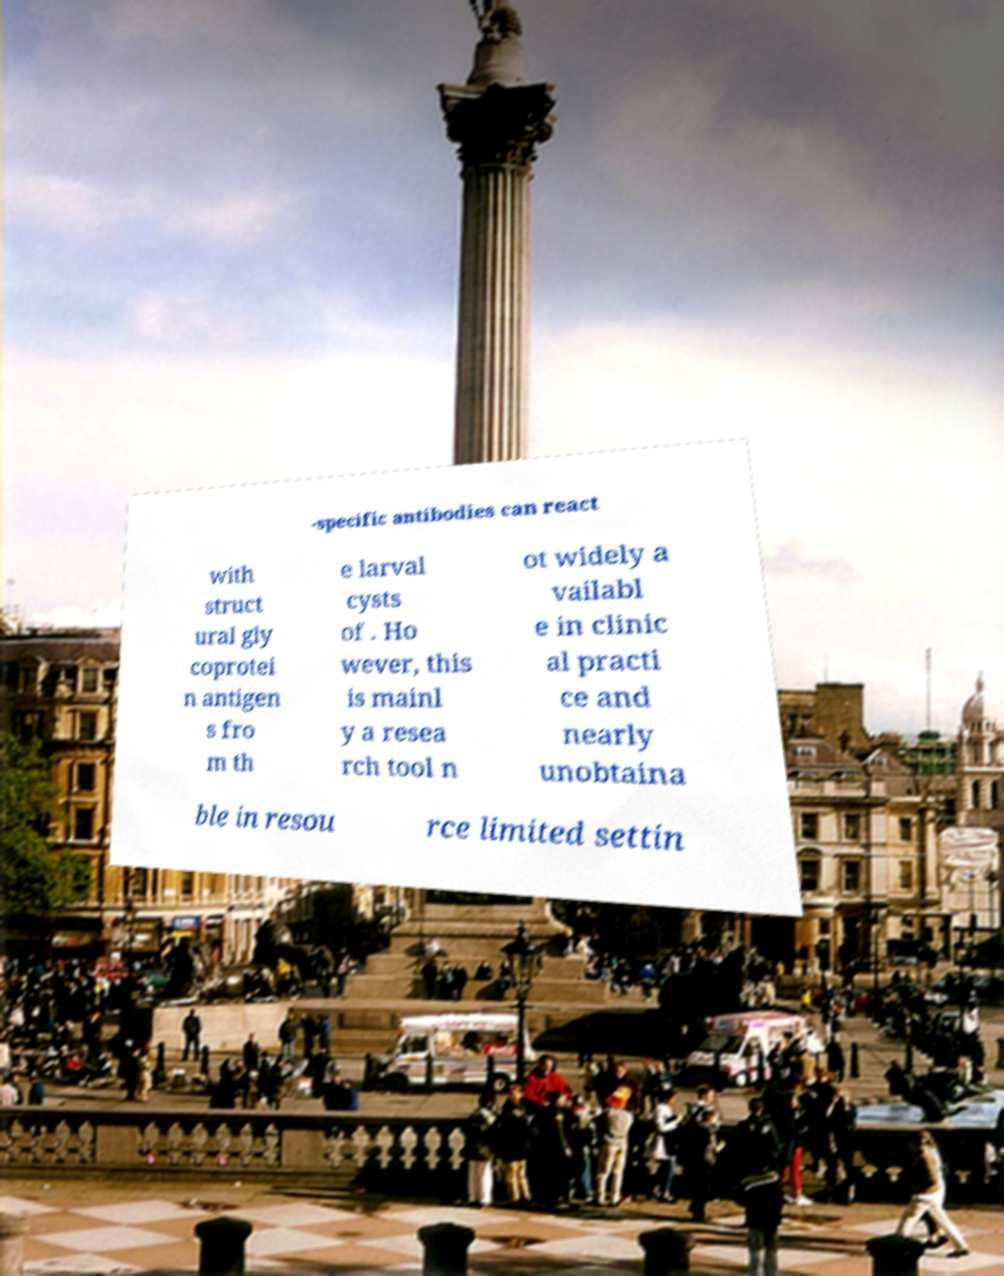I need the written content from this picture converted into text. Can you do that? -specific antibodies can react with struct ural gly coprotei n antigen s fro m th e larval cysts of . Ho wever, this is mainl y a resea rch tool n ot widely a vailabl e in clinic al practi ce and nearly unobtaina ble in resou rce limited settin 